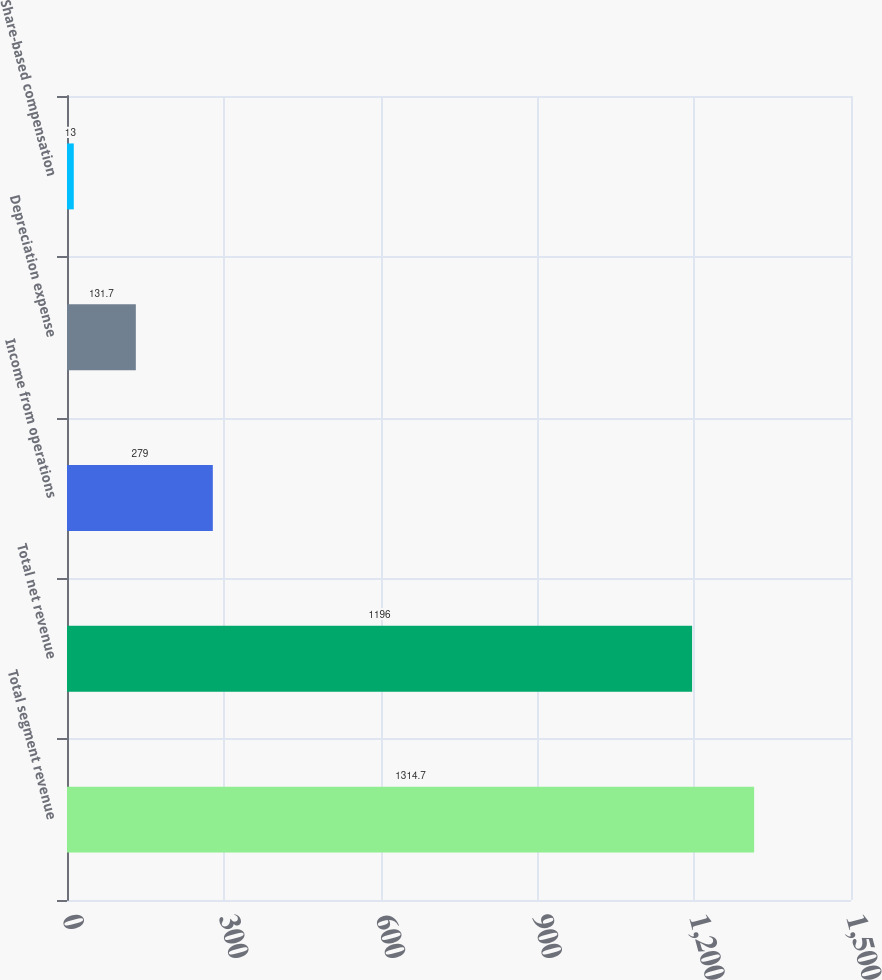Convert chart to OTSL. <chart><loc_0><loc_0><loc_500><loc_500><bar_chart><fcel>Total segment revenue<fcel>Total net revenue<fcel>Income from operations<fcel>Depreciation expense<fcel>Share-based compensation<nl><fcel>1314.7<fcel>1196<fcel>279<fcel>131.7<fcel>13<nl></chart> 